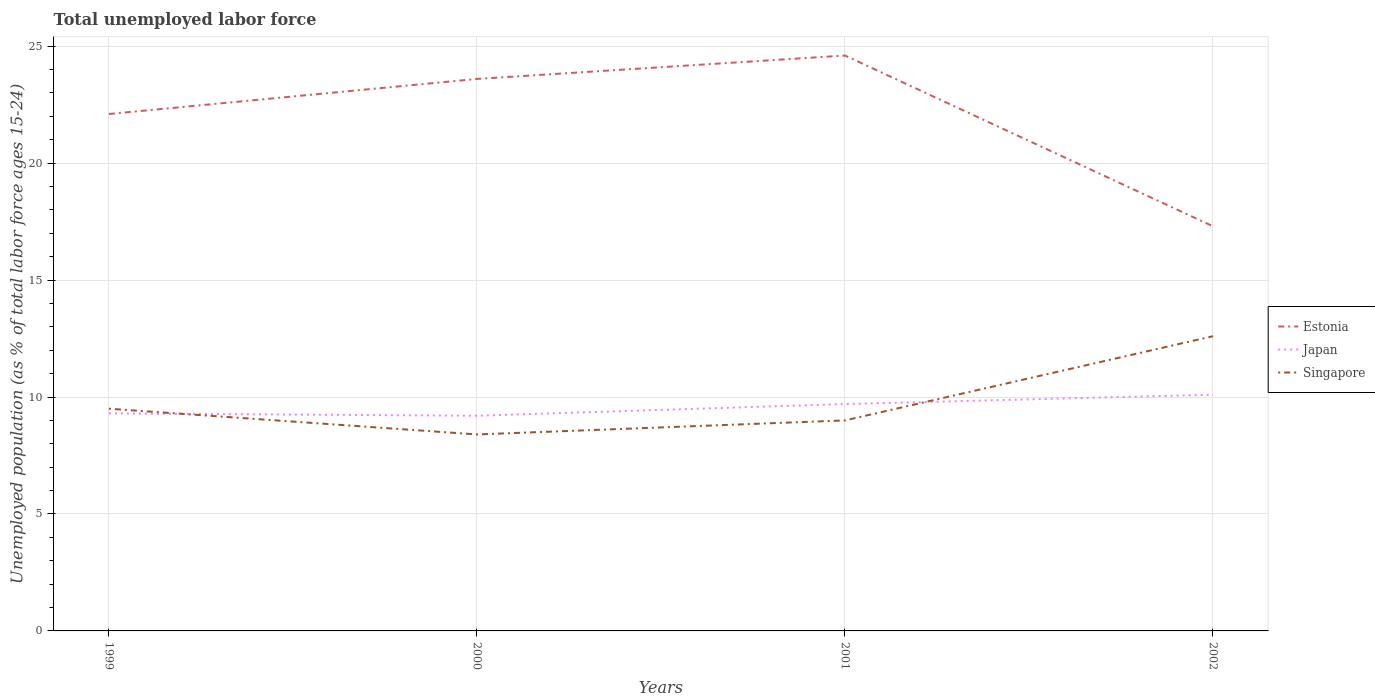How many different coloured lines are there?
Keep it short and to the point. 3. Does the line corresponding to Estonia intersect with the line corresponding to Japan?
Your answer should be compact. No. Is the number of lines equal to the number of legend labels?
Ensure brevity in your answer.  Yes. Across all years, what is the maximum percentage of unemployed population in in Singapore?
Provide a short and direct response. 8.4. What is the total percentage of unemployed population in in Singapore in the graph?
Ensure brevity in your answer.  1.1. What is the difference between the highest and the second highest percentage of unemployed population in in Japan?
Provide a succinct answer. 0.9. What is the difference between the highest and the lowest percentage of unemployed population in in Estonia?
Your answer should be compact. 3. Is the percentage of unemployed population in in Singapore strictly greater than the percentage of unemployed population in in Estonia over the years?
Ensure brevity in your answer.  Yes. What is the difference between two consecutive major ticks on the Y-axis?
Your answer should be compact. 5. Are the values on the major ticks of Y-axis written in scientific E-notation?
Your response must be concise. No. Does the graph contain grids?
Ensure brevity in your answer.  Yes. How are the legend labels stacked?
Offer a terse response. Vertical. What is the title of the graph?
Make the answer very short. Total unemployed labor force. What is the label or title of the X-axis?
Your response must be concise. Years. What is the label or title of the Y-axis?
Ensure brevity in your answer.  Unemployed population (as % of total labor force ages 15-24). What is the Unemployed population (as % of total labor force ages 15-24) in Estonia in 1999?
Your answer should be compact. 22.1. What is the Unemployed population (as % of total labor force ages 15-24) in Japan in 1999?
Your response must be concise. 9.3. What is the Unemployed population (as % of total labor force ages 15-24) of Singapore in 1999?
Make the answer very short. 9.5. What is the Unemployed population (as % of total labor force ages 15-24) of Estonia in 2000?
Provide a succinct answer. 23.6. What is the Unemployed population (as % of total labor force ages 15-24) in Japan in 2000?
Give a very brief answer. 9.2. What is the Unemployed population (as % of total labor force ages 15-24) in Singapore in 2000?
Provide a short and direct response. 8.4. What is the Unemployed population (as % of total labor force ages 15-24) in Estonia in 2001?
Your answer should be very brief. 24.6. What is the Unemployed population (as % of total labor force ages 15-24) in Japan in 2001?
Offer a very short reply. 9.7. What is the Unemployed population (as % of total labor force ages 15-24) of Estonia in 2002?
Your response must be concise. 17.3. What is the Unemployed population (as % of total labor force ages 15-24) in Japan in 2002?
Offer a very short reply. 10.1. What is the Unemployed population (as % of total labor force ages 15-24) of Singapore in 2002?
Offer a terse response. 12.6. Across all years, what is the maximum Unemployed population (as % of total labor force ages 15-24) in Estonia?
Provide a succinct answer. 24.6. Across all years, what is the maximum Unemployed population (as % of total labor force ages 15-24) in Japan?
Keep it short and to the point. 10.1. Across all years, what is the maximum Unemployed population (as % of total labor force ages 15-24) in Singapore?
Offer a very short reply. 12.6. Across all years, what is the minimum Unemployed population (as % of total labor force ages 15-24) of Estonia?
Make the answer very short. 17.3. Across all years, what is the minimum Unemployed population (as % of total labor force ages 15-24) in Japan?
Offer a very short reply. 9.2. Across all years, what is the minimum Unemployed population (as % of total labor force ages 15-24) of Singapore?
Make the answer very short. 8.4. What is the total Unemployed population (as % of total labor force ages 15-24) in Estonia in the graph?
Offer a very short reply. 87.6. What is the total Unemployed population (as % of total labor force ages 15-24) of Japan in the graph?
Your answer should be very brief. 38.3. What is the total Unemployed population (as % of total labor force ages 15-24) of Singapore in the graph?
Your answer should be very brief. 39.5. What is the difference between the Unemployed population (as % of total labor force ages 15-24) of Estonia in 1999 and that in 2000?
Make the answer very short. -1.5. What is the difference between the Unemployed population (as % of total labor force ages 15-24) in Singapore in 1999 and that in 2000?
Your answer should be very brief. 1.1. What is the difference between the Unemployed population (as % of total labor force ages 15-24) of Singapore in 1999 and that in 2001?
Provide a short and direct response. 0.5. What is the difference between the Unemployed population (as % of total labor force ages 15-24) in Estonia in 1999 and that in 2002?
Provide a short and direct response. 4.8. What is the difference between the Unemployed population (as % of total labor force ages 15-24) of Estonia in 2000 and that in 2001?
Ensure brevity in your answer.  -1. What is the difference between the Unemployed population (as % of total labor force ages 15-24) in Japan in 2000 and that in 2001?
Provide a succinct answer. -0.5. What is the difference between the Unemployed population (as % of total labor force ages 15-24) in Singapore in 2000 and that in 2001?
Offer a very short reply. -0.6. What is the difference between the Unemployed population (as % of total labor force ages 15-24) of Japan in 2000 and that in 2002?
Your answer should be compact. -0.9. What is the difference between the Unemployed population (as % of total labor force ages 15-24) of Estonia in 2001 and that in 2002?
Give a very brief answer. 7.3. What is the difference between the Unemployed population (as % of total labor force ages 15-24) in Japan in 2001 and that in 2002?
Provide a succinct answer. -0.4. What is the difference between the Unemployed population (as % of total labor force ages 15-24) of Estonia in 1999 and the Unemployed population (as % of total labor force ages 15-24) of Singapore in 2000?
Offer a very short reply. 13.7. What is the difference between the Unemployed population (as % of total labor force ages 15-24) of Japan in 1999 and the Unemployed population (as % of total labor force ages 15-24) of Singapore in 2000?
Offer a terse response. 0.9. What is the difference between the Unemployed population (as % of total labor force ages 15-24) in Estonia in 1999 and the Unemployed population (as % of total labor force ages 15-24) in Japan in 2001?
Keep it short and to the point. 12.4. What is the difference between the Unemployed population (as % of total labor force ages 15-24) in Estonia in 1999 and the Unemployed population (as % of total labor force ages 15-24) in Singapore in 2001?
Make the answer very short. 13.1. What is the difference between the Unemployed population (as % of total labor force ages 15-24) in Estonia in 2000 and the Unemployed population (as % of total labor force ages 15-24) in Japan in 2001?
Give a very brief answer. 13.9. What is the difference between the Unemployed population (as % of total labor force ages 15-24) in Estonia in 2000 and the Unemployed population (as % of total labor force ages 15-24) in Singapore in 2002?
Your answer should be compact. 11. What is the average Unemployed population (as % of total labor force ages 15-24) of Estonia per year?
Your answer should be very brief. 21.9. What is the average Unemployed population (as % of total labor force ages 15-24) in Japan per year?
Make the answer very short. 9.57. What is the average Unemployed population (as % of total labor force ages 15-24) of Singapore per year?
Ensure brevity in your answer.  9.88. In the year 1999, what is the difference between the Unemployed population (as % of total labor force ages 15-24) of Estonia and Unemployed population (as % of total labor force ages 15-24) of Japan?
Offer a very short reply. 12.8. In the year 1999, what is the difference between the Unemployed population (as % of total labor force ages 15-24) of Estonia and Unemployed population (as % of total labor force ages 15-24) of Singapore?
Make the answer very short. 12.6. In the year 1999, what is the difference between the Unemployed population (as % of total labor force ages 15-24) of Japan and Unemployed population (as % of total labor force ages 15-24) of Singapore?
Make the answer very short. -0.2. In the year 2000, what is the difference between the Unemployed population (as % of total labor force ages 15-24) of Estonia and Unemployed population (as % of total labor force ages 15-24) of Japan?
Offer a terse response. 14.4. In the year 2000, what is the difference between the Unemployed population (as % of total labor force ages 15-24) of Japan and Unemployed population (as % of total labor force ages 15-24) of Singapore?
Make the answer very short. 0.8. In the year 2001, what is the difference between the Unemployed population (as % of total labor force ages 15-24) of Estonia and Unemployed population (as % of total labor force ages 15-24) of Japan?
Your response must be concise. 14.9. In the year 2001, what is the difference between the Unemployed population (as % of total labor force ages 15-24) of Japan and Unemployed population (as % of total labor force ages 15-24) of Singapore?
Keep it short and to the point. 0.7. In the year 2002, what is the difference between the Unemployed population (as % of total labor force ages 15-24) of Estonia and Unemployed population (as % of total labor force ages 15-24) of Japan?
Make the answer very short. 7.2. In the year 2002, what is the difference between the Unemployed population (as % of total labor force ages 15-24) of Estonia and Unemployed population (as % of total labor force ages 15-24) of Singapore?
Provide a succinct answer. 4.7. What is the ratio of the Unemployed population (as % of total labor force ages 15-24) of Estonia in 1999 to that in 2000?
Your response must be concise. 0.94. What is the ratio of the Unemployed population (as % of total labor force ages 15-24) in Japan in 1999 to that in 2000?
Keep it short and to the point. 1.01. What is the ratio of the Unemployed population (as % of total labor force ages 15-24) of Singapore in 1999 to that in 2000?
Provide a short and direct response. 1.13. What is the ratio of the Unemployed population (as % of total labor force ages 15-24) in Estonia in 1999 to that in 2001?
Ensure brevity in your answer.  0.9. What is the ratio of the Unemployed population (as % of total labor force ages 15-24) in Japan in 1999 to that in 2001?
Provide a short and direct response. 0.96. What is the ratio of the Unemployed population (as % of total labor force ages 15-24) in Singapore in 1999 to that in 2001?
Ensure brevity in your answer.  1.06. What is the ratio of the Unemployed population (as % of total labor force ages 15-24) in Estonia in 1999 to that in 2002?
Your answer should be compact. 1.28. What is the ratio of the Unemployed population (as % of total labor force ages 15-24) in Japan in 1999 to that in 2002?
Offer a terse response. 0.92. What is the ratio of the Unemployed population (as % of total labor force ages 15-24) in Singapore in 1999 to that in 2002?
Keep it short and to the point. 0.75. What is the ratio of the Unemployed population (as % of total labor force ages 15-24) of Estonia in 2000 to that in 2001?
Keep it short and to the point. 0.96. What is the ratio of the Unemployed population (as % of total labor force ages 15-24) of Japan in 2000 to that in 2001?
Keep it short and to the point. 0.95. What is the ratio of the Unemployed population (as % of total labor force ages 15-24) of Estonia in 2000 to that in 2002?
Your answer should be very brief. 1.36. What is the ratio of the Unemployed population (as % of total labor force ages 15-24) of Japan in 2000 to that in 2002?
Give a very brief answer. 0.91. What is the ratio of the Unemployed population (as % of total labor force ages 15-24) of Estonia in 2001 to that in 2002?
Ensure brevity in your answer.  1.42. What is the ratio of the Unemployed population (as % of total labor force ages 15-24) of Japan in 2001 to that in 2002?
Give a very brief answer. 0.96. What is the ratio of the Unemployed population (as % of total labor force ages 15-24) in Singapore in 2001 to that in 2002?
Your response must be concise. 0.71. What is the difference between the highest and the second highest Unemployed population (as % of total labor force ages 15-24) of Japan?
Your answer should be very brief. 0.4. What is the difference between the highest and the second highest Unemployed population (as % of total labor force ages 15-24) in Singapore?
Provide a short and direct response. 3.1. What is the difference between the highest and the lowest Unemployed population (as % of total labor force ages 15-24) in Estonia?
Ensure brevity in your answer.  7.3. 